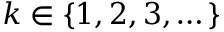Convert formula to latex. <formula><loc_0><loc_0><loc_500><loc_500>k \in \{ 1 , 2 , 3 , \dots \}</formula> 